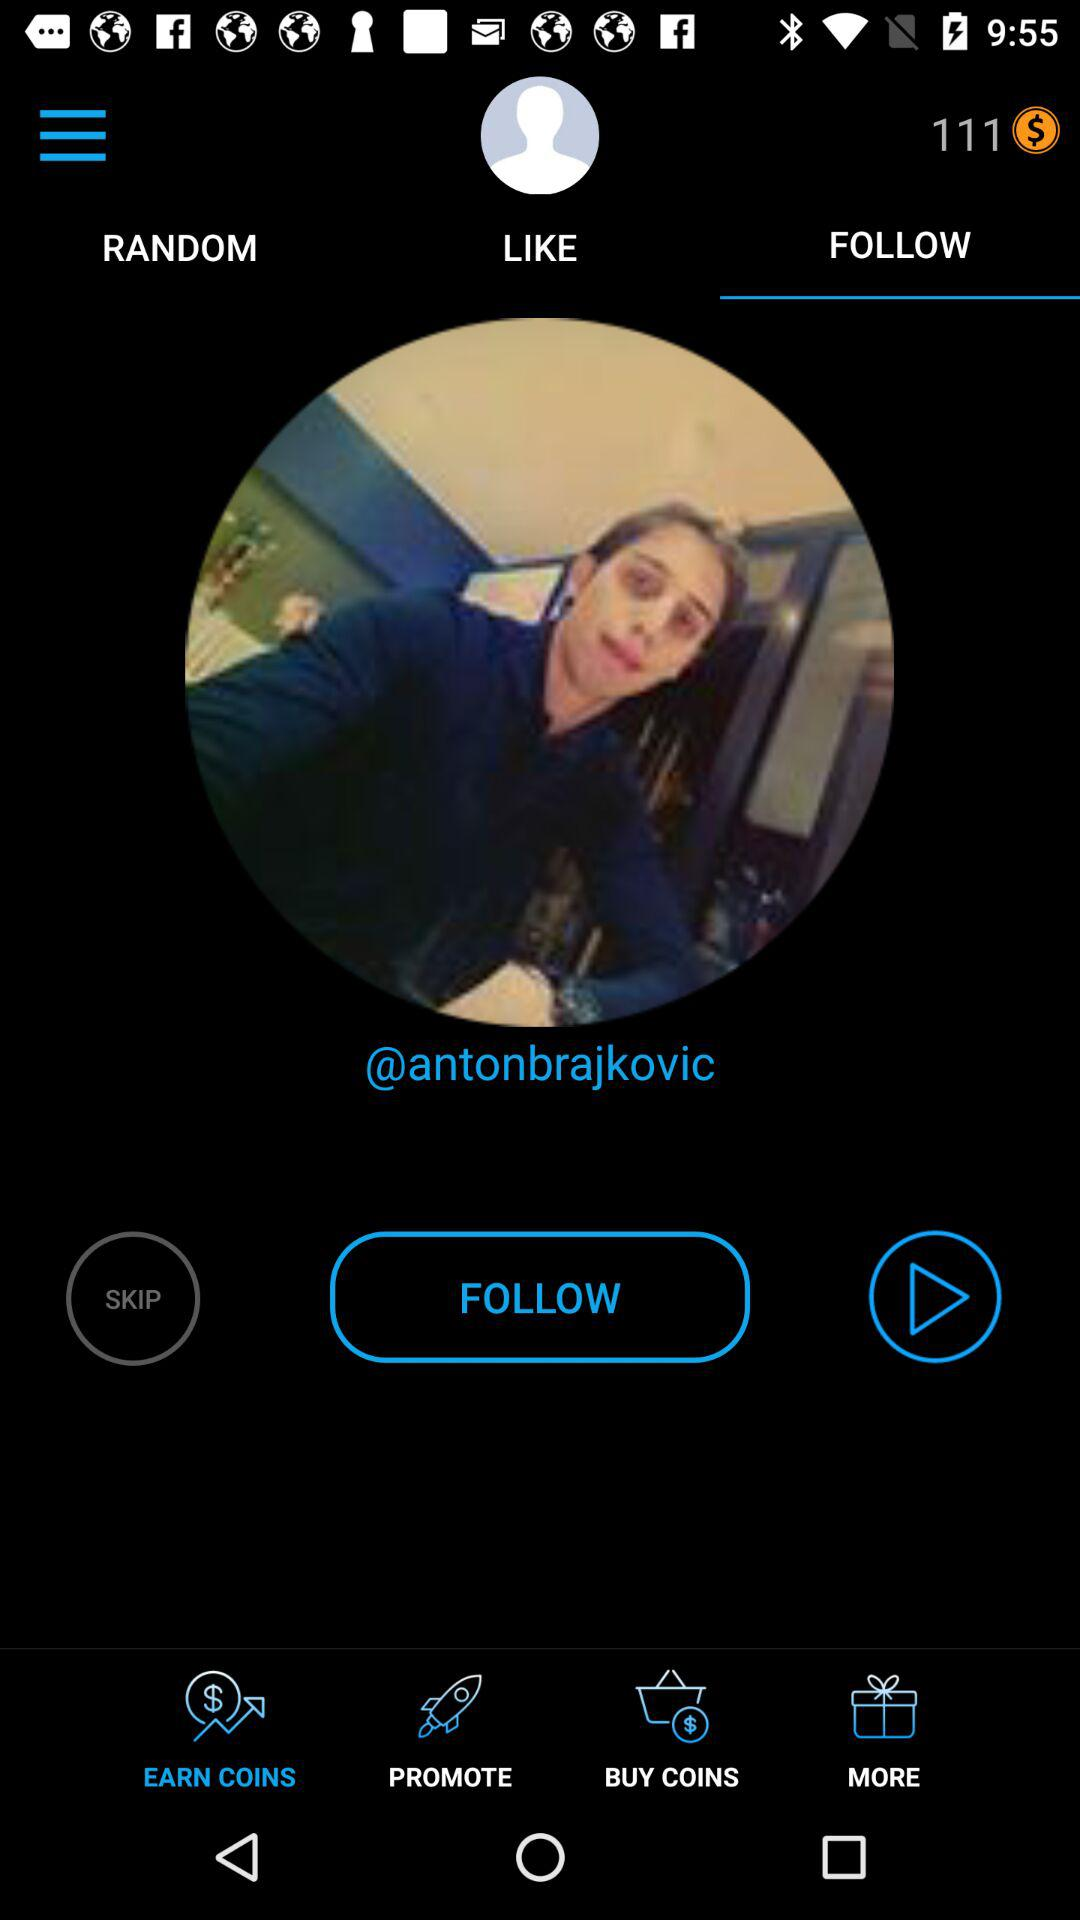Which tab is selected? The selected tabs are "FOLLOW" and "EARN COINS". 